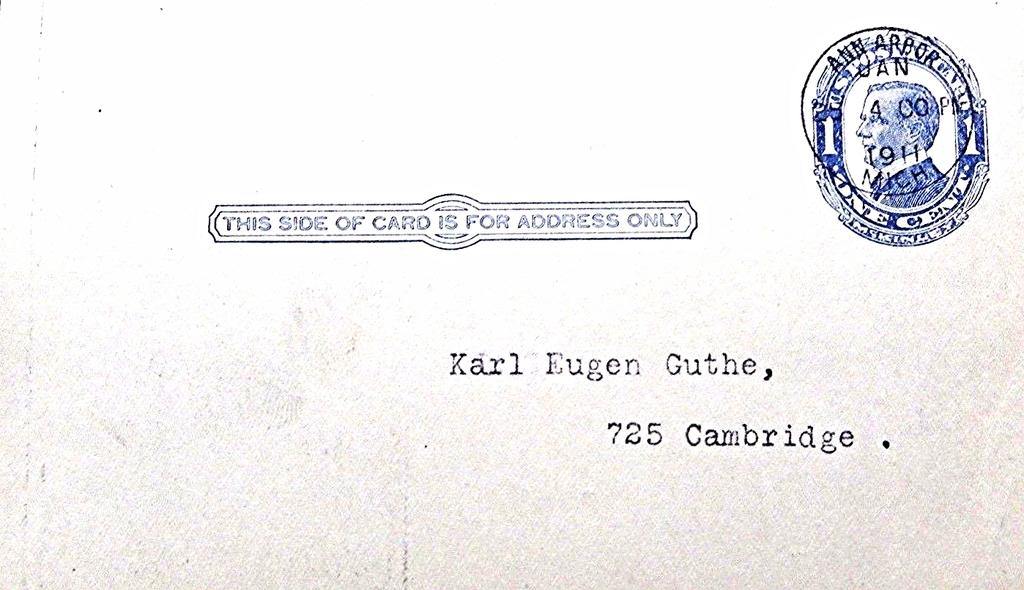Only for what is this side of the card?
Offer a very short reply. Address. What name is written?
Your answer should be very brief. Karl eugen guthe. 